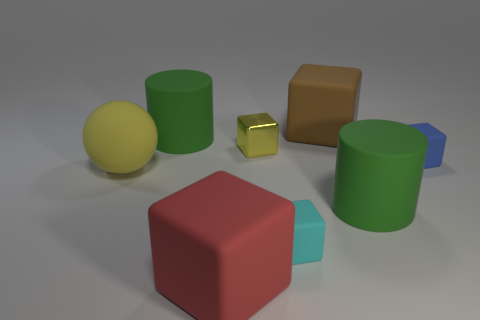Subtract 2 blocks. How many blocks are left? 3 Subtract all cyan cubes. How many cubes are left? 4 Subtract all gray blocks. Subtract all gray balls. How many blocks are left? 5 Add 1 tiny purple spheres. How many objects exist? 9 Subtract all balls. How many objects are left? 7 Subtract all small objects. Subtract all large green cylinders. How many objects are left? 3 Add 5 big brown objects. How many big brown objects are left? 6 Add 4 blue things. How many blue things exist? 5 Subtract 1 yellow spheres. How many objects are left? 7 